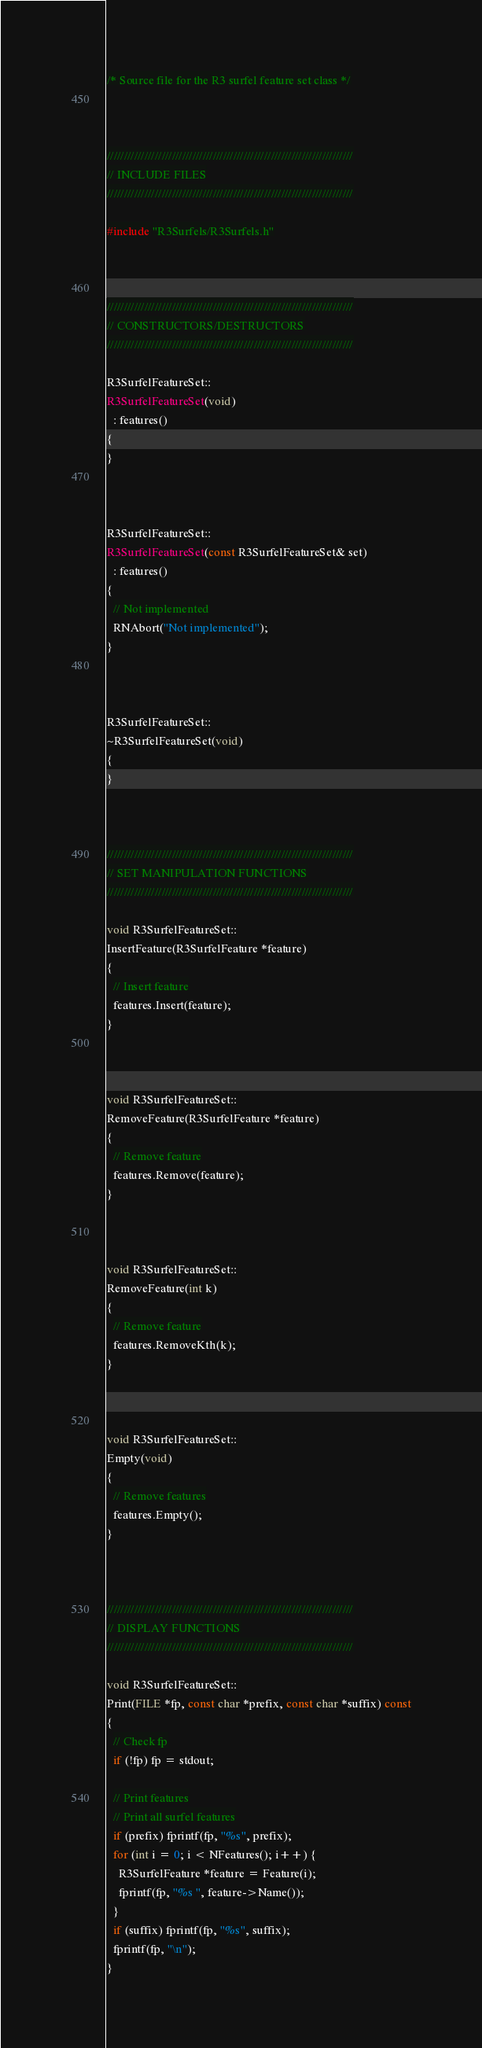<code> <loc_0><loc_0><loc_500><loc_500><_C++_>/* Source file for the R3 surfel feature set class */



////////////////////////////////////////////////////////////////////////
// INCLUDE FILES
////////////////////////////////////////////////////////////////////////

#include "R3Surfels/R3Surfels.h"



////////////////////////////////////////////////////////////////////////
// CONSTRUCTORS/DESTRUCTORS
////////////////////////////////////////////////////////////////////////

R3SurfelFeatureSet::
R3SurfelFeatureSet(void)
  : features()
{
}



R3SurfelFeatureSet::
R3SurfelFeatureSet(const R3SurfelFeatureSet& set)
  : features()
{
  // Not implemented
  RNAbort("Not implemented");
}



R3SurfelFeatureSet::
~R3SurfelFeatureSet(void)
{
}



////////////////////////////////////////////////////////////////////////
// SET MANIPULATION FUNCTIONS
////////////////////////////////////////////////////////////////////////

void R3SurfelFeatureSet::
InsertFeature(R3SurfelFeature *feature)
{
  // Insert feature
  features.Insert(feature);
}



void R3SurfelFeatureSet::
RemoveFeature(R3SurfelFeature *feature)
{
  // Remove feature
  features.Remove(feature);
}



void R3SurfelFeatureSet::
RemoveFeature(int k)
{
  // Remove feature
  features.RemoveKth(k);
}



void R3SurfelFeatureSet::
Empty(void)
{
  // Remove features
  features.Empty();
}



////////////////////////////////////////////////////////////////////////
// DISPLAY FUNCTIONS
////////////////////////////////////////////////////////////////////////

void R3SurfelFeatureSet::
Print(FILE *fp, const char *prefix, const char *suffix) const
{
  // Check fp
  if (!fp) fp = stdout;

  // Print features
  // Print all surfel features
  if (prefix) fprintf(fp, "%s", prefix);
  for (int i = 0; i < NFeatures(); i++) {
    R3SurfelFeature *feature = Feature(i);
    fprintf(fp, "%s ", feature->Name());
  }
  if (suffix) fprintf(fp, "%s", suffix);
  fprintf(fp, "\n");
}


</code> 